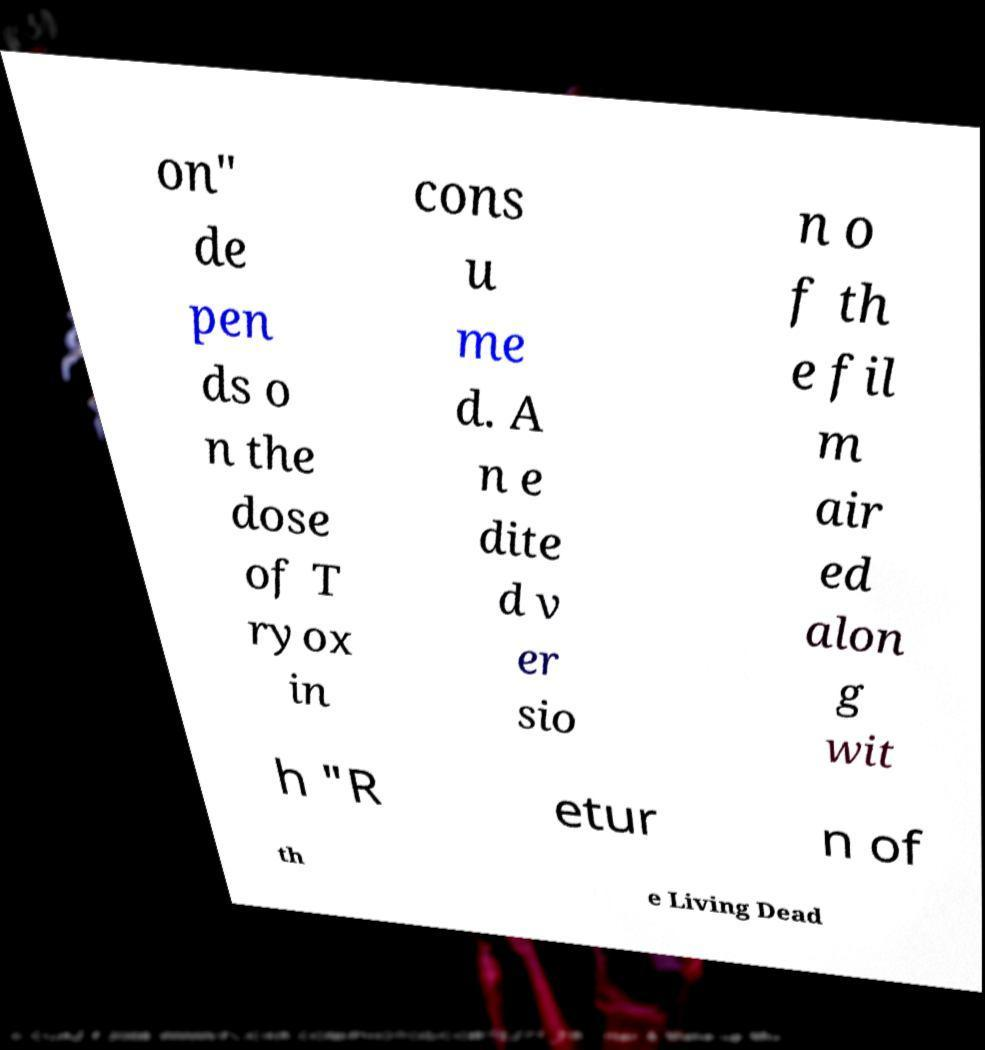Can you accurately transcribe the text from the provided image for me? on" de pen ds o n the dose of T ryox in cons u me d. A n e dite d v er sio n o f th e fil m air ed alon g wit h "R etur n of th e Living Dead 